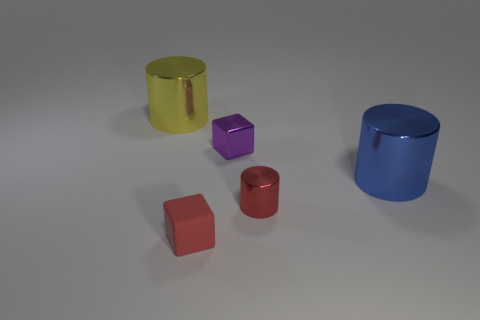How many other blue shiny things have the same size as the blue thing?
Provide a succinct answer. 0. There is another large cylinder that is the same material as the blue cylinder; what is its color?
Provide a short and direct response. Yellow. Is the number of tiny red metal objects less than the number of large purple cylinders?
Make the answer very short. No. What number of yellow objects are matte objects or shiny things?
Give a very brief answer. 1. How many objects are in front of the purple thing and on the left side of the red cylinder?
Make the answer very short. 1. Does the blue cylinder have the same material as the small red cube?
Ensure brevity in your answer.  No. There is another thing that is the same size as the blue object; what shape is it?
Offer a terse response. Cylinder. Are there more large blue metal objects than big purple matte spheres?
Your response must be concise. Yes. There is a thing that is on the left side of the small purple metallic block and in front of the blue thing; what is it made of?
Keep it short and to the point. Rubber. How many other things are there of the same material as the blue object?
Offer a very short reply. 3. 